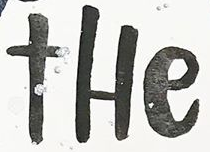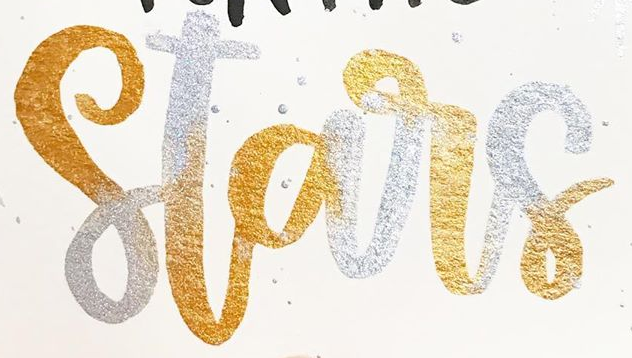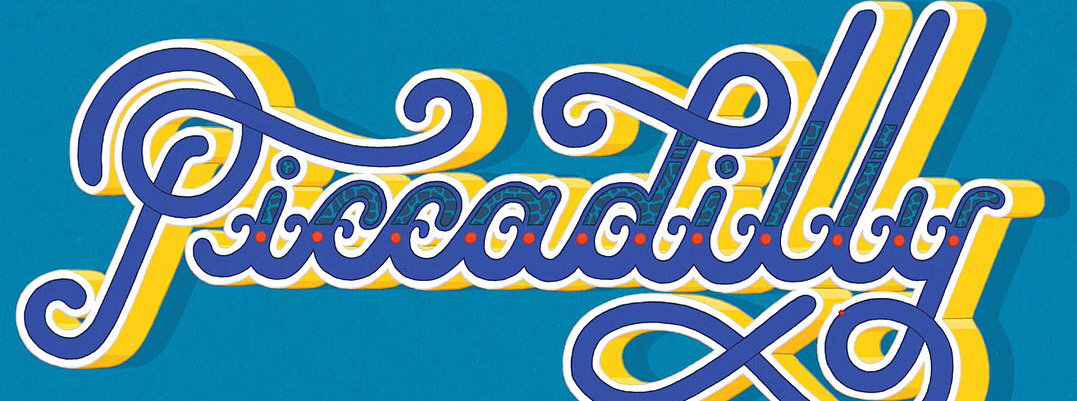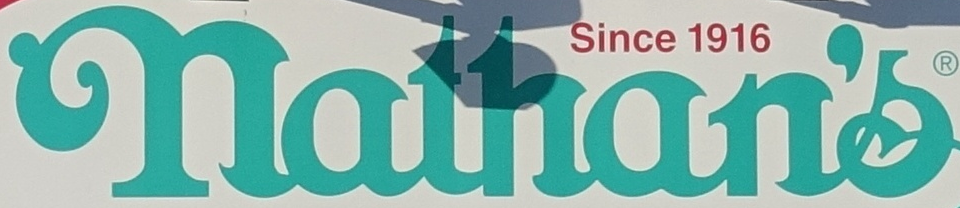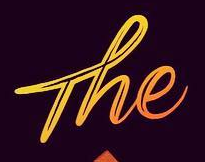Read the text from these images in sequence, separated by a semicolon. tHe; Stars; Piccadilly; nathan's; The 